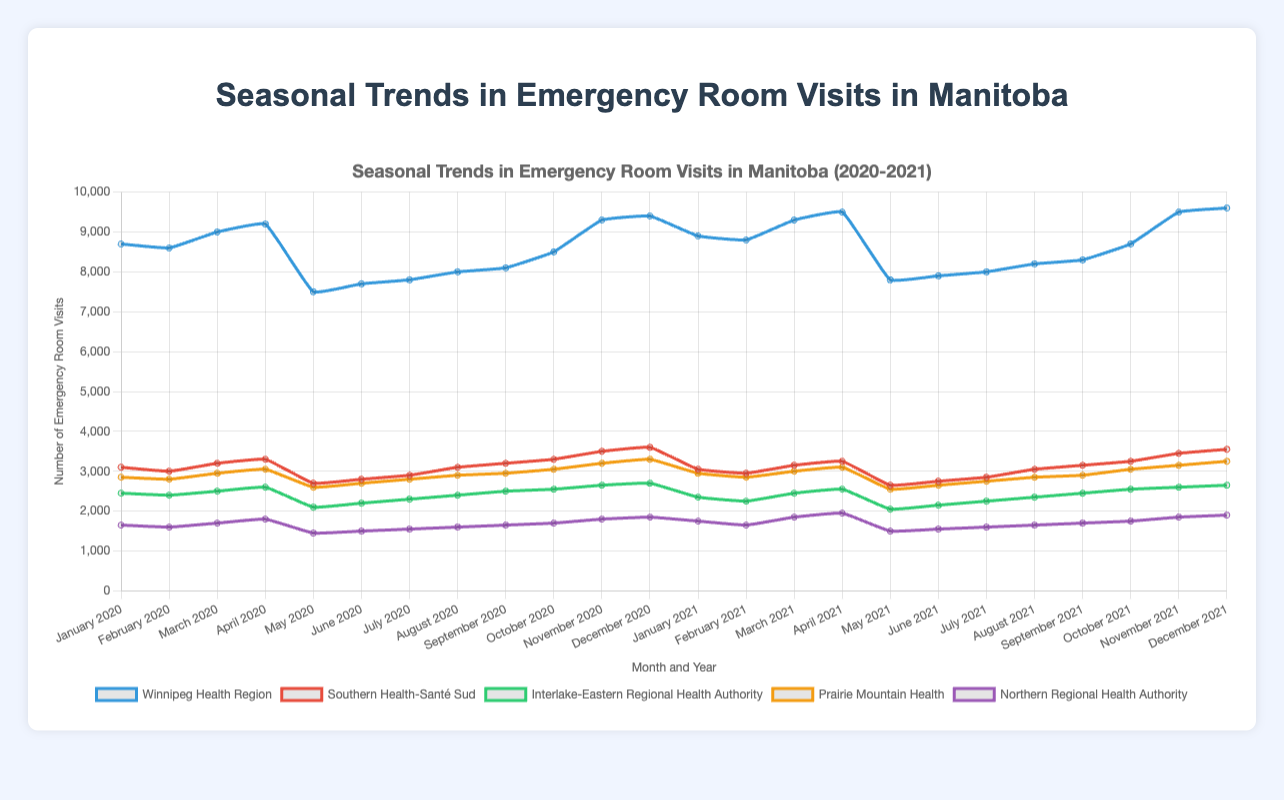What's the total number of emergency room visits in the Prairie Mountain Health region in both years combined? To find the total number of emergency room visits in Prairie Mountain Health region in 2020 and 2021, sum all the visits for each month's data. For 2020, the visits are: 2850, 2800, 2950, 3050, 2600, 2700, 2800, 2900, 2950, 3050, 3200, 3300; for 2021, the visits are: 2950, 2850, 3000, 3100, 2550, 2650, 2750, 2850, 2900, 3050, 3150, 3250. Summing these gives us 34,300 for both years.
Answer: 34,300 During which month did the Northern Regional Health Authority see the highest number of emergency room visits? Refer to the data for the Northern Regional Health Authority. The highest value is in December 2021, with 1900 visits.
Answer: December 2021 Which health region had the most significant drop in emergency room visits from January to May 2020? Subtract the visits in May from January for each region to identify the largest drop: Winnipeg Health Region (8700 - 7500), Southern Health-Santé Sud (3100 - 2700), Interlake-Eastern Regional Health Authority (2450 - 2100), Prairie Mountain Health (2850 - 2600), Northern Regional Health Authority (1650 - 1450). The Interlake-Eastern Regional Health Authority has the largest drop of 350 visits.
Answer: Interlake-Eastern Regional Health Authority What is the average number of emergency room visits in Winnipeg Health Region over the two years? Calculate the total sum of visits across both years and divide by the number of months (24): Sum of visits from Winnipeg Health Region = 207400; average = 207400 / 24 = 8641.67.
Answer: 8641.67 Compare the number of emergency room visits between the Southern Health-Santé Sud and Interlake-Eastern Regional Health Authority in July 2021. Which one is higher and by how much? Compare the visits in July 2021: Southern Health-Santé Sud (2850), Interlake-Eastern Regional Health Authority (2250). The difference is 2850 - 2250 = 600. Southern Health-Santé Sud has 600 more visits.
Answer: Southern Health-Santé Sud by 600 In 2021, which month and health region combination had the lowest number of emergency room visits? Look at the 2021 data across all regions to find the lowest value: Northern Regional Health Authority in May with 1500 visits.
Answer: Northern Regional Health Authority, May What is the median number of emergency room visits for the Interlake-Eastern Regional Health Authority in 2020? Arrange the visits of the Interlake-Eastern Regional Health Authority for 2020 in ascending order: 2100, 2200, 2300, 2400, 2400, 2450, 2500, 2550, 2600, 2650, 2700. The median is the middle value: 2450.
Answer: 2450 In which month of 2020 did Winnipeg Health Region see the sharpest increase in emergency room visits compared to the previous month? Subtract the visit numbers of each month from the previous month: January (-), February (-100), March (+400), April (+200), May (-1700), June (+200), July (+100), August (+200), September (+100), October (+400), November (+800), December (+100). The sharpest increase is between May and June (+2500).
Answer: June 